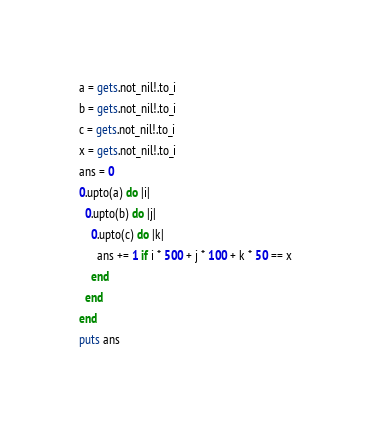Convert code to text. <code><loc_0><loc_0><loc_500><loc_500><_Crystal_>a = gets.not_nil!.to_i
b = gets.not_nil!.to_i
c = gets.not_nil!.to_i
x = gets.not_nil!.to_i
ans = 0
0.upto(a) do |i|
  0.upto(b) do |j|
    0.upto(c) do |k|
      ans += 1 if i * 500 + j * 100 + k * 50 == x
    end
  end
end
puts ans
</code> 